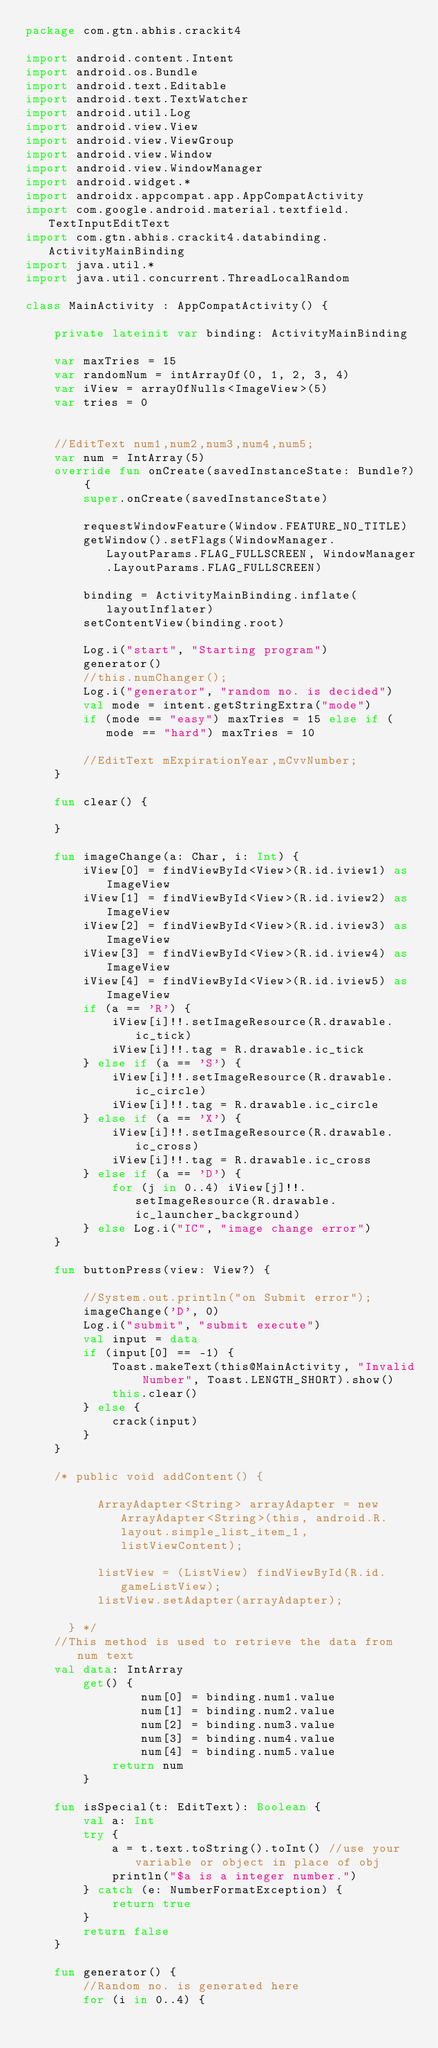<code> <loc_0><loc_0><loc_500><loc_500><_Kotlin_>package com.gtn.abhis.crackit4

import android.content.Intent
import android.os.Bundle
import android.text.Editable
import android.text.TextWatcher
import android.util.Log
import android.view.View
import android.view.ViewGroup
import android.view.Window
import android.view.WindowManager
import android.widget.*
import androidx.appcompat.app.AppCompatActivity
import com.google.android.material.textfield.TextInputEditText
import com.gtn.abhis.crackit4.databinding.ActivityMainBinding
import java.util.*
import java.util.concurrent.ThreadLocalRandom

class MainActivity : AppCompatActivity() {

    private lateinit var binding: ActivityMainBinding

    var maxTries = 15
    var randomNum = intArrayOf(0, 1, 2, 3, 4)
    var iView = arrayOfNulls<ImageView>(5)
    var tries = 0


    //EditText num1,num2,num3,num4,num5;
    var num = IntArray(5)
    override fun onCreate(savedInstanceState: Bundle?) {
        super.onCreate(savedInstanceState)

        requestWindowFeature(Window.FEATURE_NO_TITLE)
        getWindow().setFlags(WindowManager.LayoutParams.FLAG_FULLSCREEN, WindowManager.LayoutParams.FLAG_FULLSCREEN)

        binding = ActivityMainBinding.inflate(layoutInflater)
        setContentView(binding.root)

        Log.i("start", "Starting program")
        generator()
        //this.numChanger();
        Log.i("generator", "random no. is decided")
        val mode = intent.getStringExtra("mode")
        if (mode == "easy") maxTries = 15 else if (mode == "hard") maxTries = 10

        //EditText mExpirationYear,mCvvNumber;
    }

    fun clear() {

    }

    fun imageChange(a: Char, i: Int) {
        iView[0] = findViewById<View>(R.id.iview1) as ImageView
        iView[1] = findViewById<View>(R.id.iview2) as ImageView
        iView[2] = findViewById<View>(R.id.iview3) as ImageView
        iView[3] = findViewById<View>(R.id.iview4) as ImageView
        iView[4] = findViewById<View>(R.id.iview5) as ImageView
        if (a == 'R') {
            iView[i]!!.setImageResource(R.drawable.ic_tick)
            iView[i]!!.tag = R.drawable.ic_tick
        } else if (a == 'S') {
            iView[i]!!.setImageResource(R.drawable.ic_circle)
            iView[i]!!.tag = R.drawable.ic_circle
        } else if (a == 'X') {
            iView[i]!!.setImageResource(R.drawable.ic_cross)
            iView[i]!!.tag = R.drawable.ic_cross
        } else if (a == 'D') {
            for (j in 0..4) iView[j]!!.setImageResource(R.drawable.ic_launcher_background)
        } else Log.i("IC", "image change error")
    }

    fun buttonPress(view: View?) {

        //System.out.println("on Submit error");
        imageChange('D', 0)
        Log.i("submit", "submit execute")
        val input = data
        if (input[0] == -1) {
            Toast.makeText(this@MainActivity, "Invalid Number", Toast.LENGTH_SHORT).show()
            this.clear()
        } else {
            crack(input)
        }
    }

    /* public void addContent() {

          ArrayAdapter<String> arrayAdapter = new ArrayAdapter<String>(this, android.R.layout.simple_list_item_1, listViewContent);

          listView = (ListView) findViewById(R.id.gameListView);
          listView.setAdapter(arrayAdapter);

      } */
    //This method is used to retrieve the data from num text
    val data: IntArray
        get() {
                num[0] = binding.num1.value
                num[1] = binding.num2.value
                num[2] = binding.num3.value
                num[3] = binding.num4.value
                num[4] = binding.num5.value
            return num
        }

    fun isSpecial(t: EditText): Boolean {
        val a: Int
        try {
            a = t.text.toString().toInt() //use your variable or object in place of obj
            println("$a is a integer number.")
        } catch (e: NumberFormatException) {
            return true
        }
        return false
    }

    fun generator() {
        //Random no. is generated here
        for (i in 0..4) {</code> 